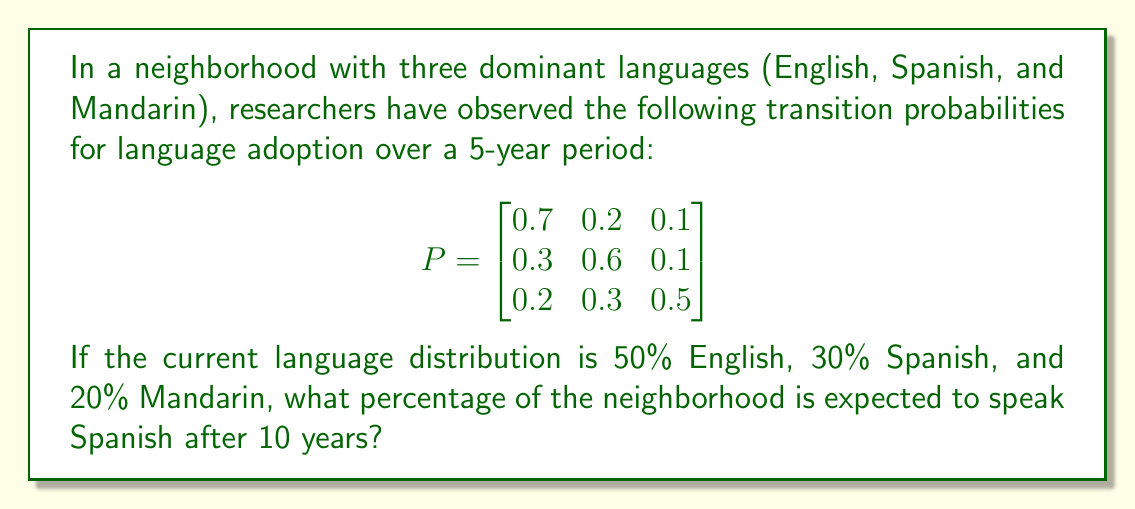Show me your answer to this math problem. To solve this problem, we'll use Markov chains to model the language evolution:

1. First, let's represent the initial state vector:
   $$v_0 = \begin{bmatrix} 0.5 \\ 0.3 \\ 0.2 \end{bmatrix}$$

2. To find the state after 10 years, we need to multiply the initial state by the transition matrix raised to the power of 2 (since each period is 5 years):
   $$v_2 = P^2 \cdot v_0$$

3. Let's calculate $P^2$:
   $$P^2 = \begin{bmatrix}
   0.7 & 0.2 & 0.1 \\
   0.3 & 0.6 & 0.1 \\
   0.2 & 0.3 & 0.5
   \end{bmatrix} \cdot \begin{bmatrix}
   0.7 & 0.2 & 0.1 \\
   0.3 & 0.6 & 0.1 \\
   0.2 & 0.3 & 0.5
   \end{bmatrix}$$

   $$P^2 = \begin{bmatrix}
   0.58 & 0.28 & 0.14 \\
   0.39 & 0.45 & 0.16 \\
   0.31 & 0.36 & 0.33
   \end{bmatrix}$$

4. Now, let's multiply $P^2$ by $v_0$:
   $$v_2 = \begin{bmatrix}
   0.58 & 0.28 & 0.14 \\
   0.39 & 0.45 & 0.16 \\
   0.31 & 0.36 & 0.33
   \end{bmatrix} \cdot \begin{bmatrix} 0.5 \\ 0.3 \\ 0.2 \end{bmatrix}$$

   $$v_2 = \begin{bmatrix}
   0.58(0.5) + 0.28(0.3) + 0.14(0.2) \\
   0.39(0.5) + 0.45(0.3) + 0.16(0.2) \\
   0.31(0.5) + 0.36(0.3) + 0.33(0.2)
   \end{bmatrix}$$

   $$v_2 = \begin{bmatrix} 0.434 \\ 0.3605 \\ 0.2055 \end{bmatrix}$$

5. The second component of $v_2$ represents the proportion speaking Spanish after 10 years, which is approximately 0.3605 or 36.05%.
Answer: 36.05% 